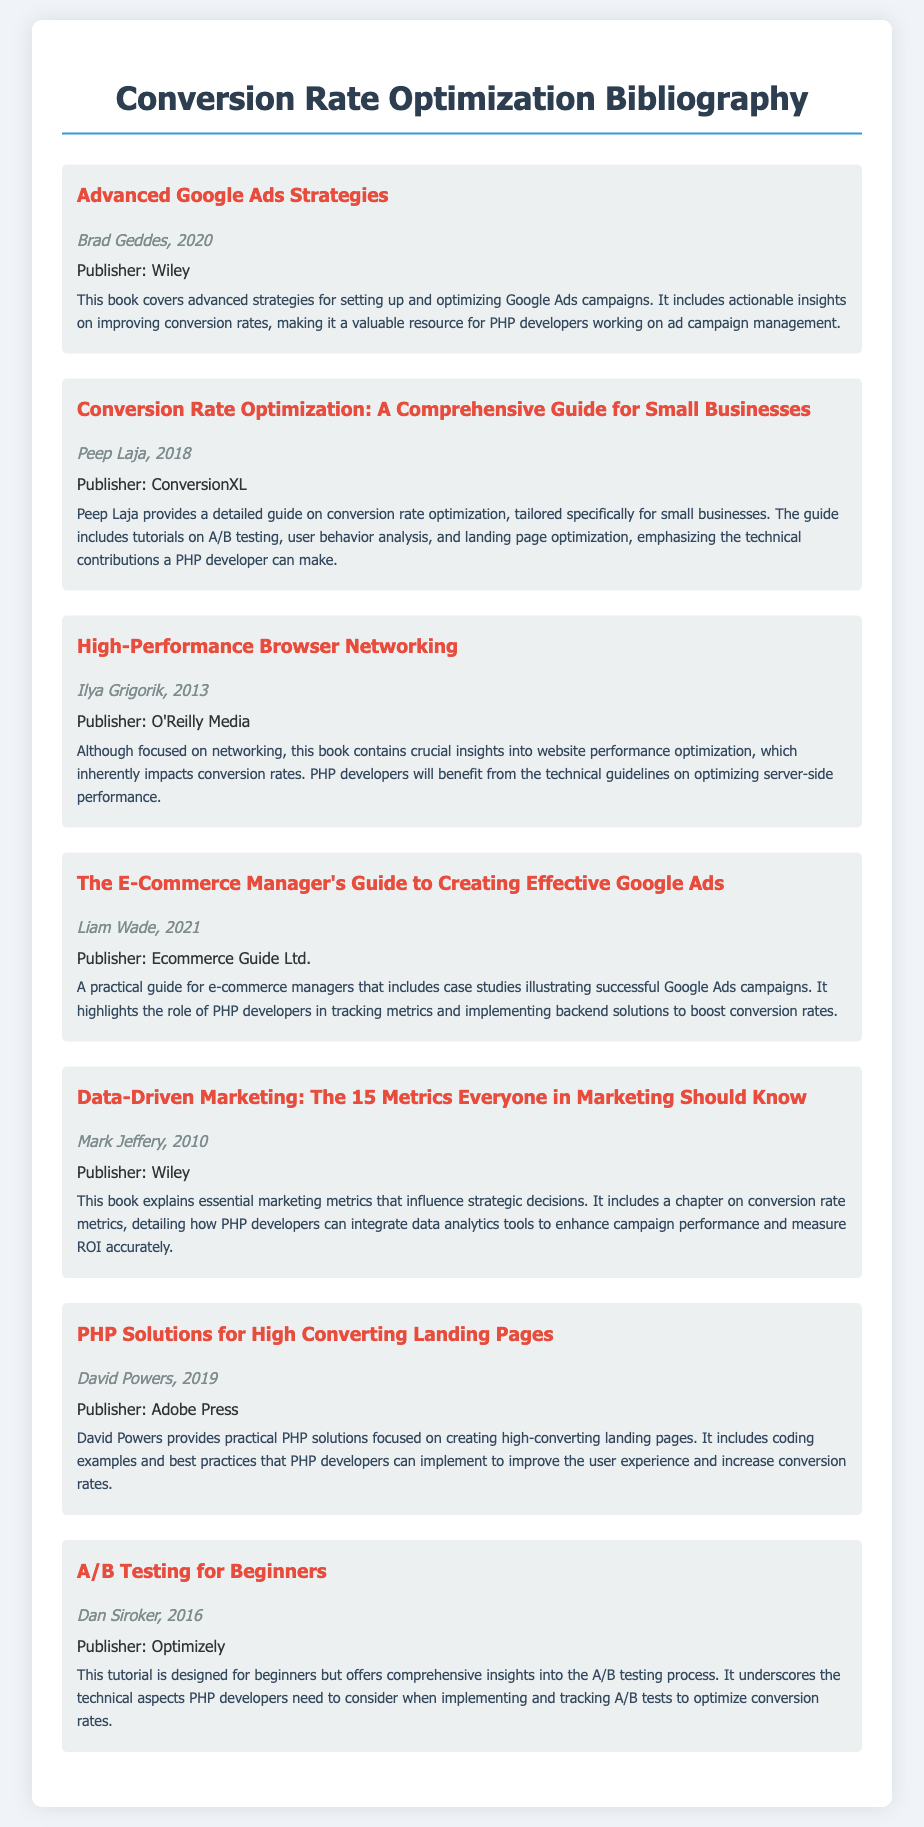what is the title of the first entry? The title is listed at the top of the first entry in the bibliography.
Answer: Advanced Google Ads Strategies who is the author of "Conversion Rate Optimization: A Comprehensive Guide for Small Businesses"? The author is mentioned directly below the title in the entry.
Answer: Peep Laja when was "High-Performance Browser Networking" published? The publication year is found in the author section of the respective entry.
Answer: 2013 which publisher released "PHP Solutions for High Converting Landing Pages"? The publisher is indicated in the entry details following the author's name.
Answer: Adobe Press name one key topic covered in "A/B Testing for Beginners". The topic is mentioned in the summary of the entry.
Answer: A/B testing process how many entries are in the bibliography? The number of entries can be counted from the visible list in the document.
Answer: 7 which book emphasizes technical contributions from PHP developers? The summary of the entries includes notes on contributions from developers.
Answer: Conversion Rate Optimization: A Comprehensive Guide for Small Businesses what is the focus of "The E-Commerce Manager's Guide to Creating Effective Google Ads"? This information is provided in the summary section of the entry.
Answer: Case studies illustrating successful Google Ads campaigns 